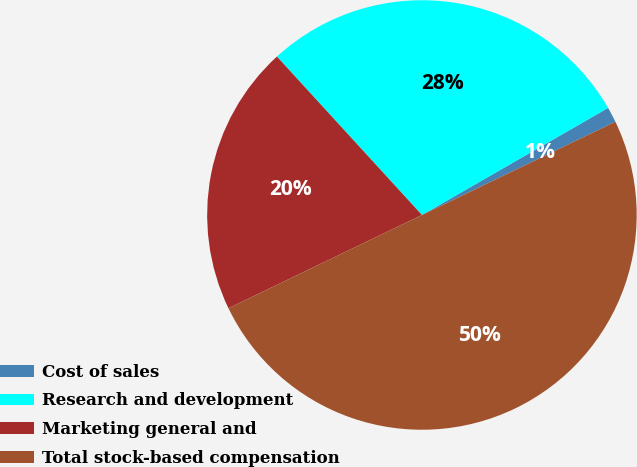Convert chart. <chart><loc_0><loc_0><loc_500><loc_500><pie_chart><fcel>Cost of sales<fcel>Research and development<fcel>Marketing general and<fcel>Total stock-based compensation<nl><fcel>1.16%<fcel>28.49%<fcel>20.35%<fcel>50.0%<nl></chart> 